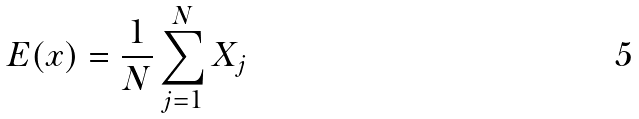Convert formula to latex. <formula><loc_0><loc_0><loc_500><loc_500>E ( x ) = \frac { 1 } { N } \sum _ { j = 1 } ^ { N } X _ { j }</formula> 